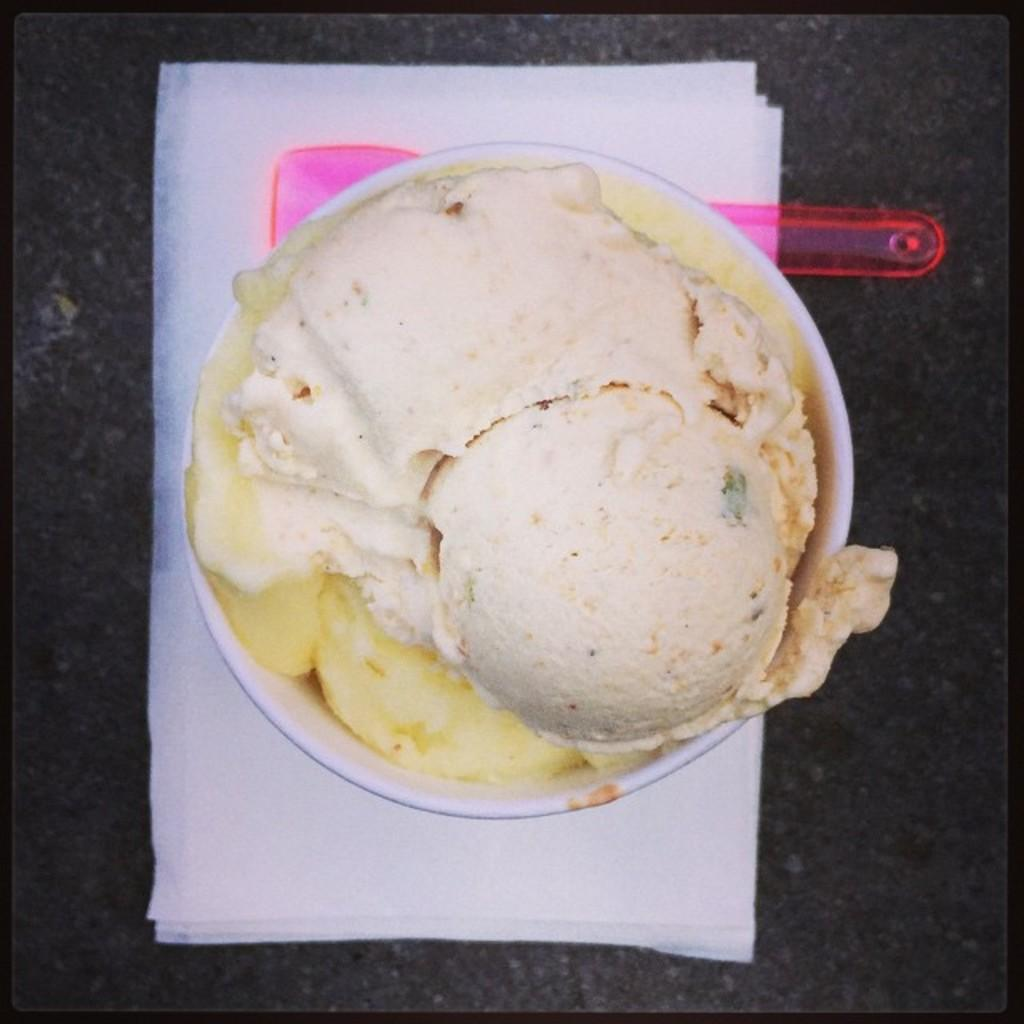What is in the bowl that is visible in the image? The bowl contains ice cream. What utensil is present in the image? There is a spoon in the image. Where is the bowl and spoon located? The bowl and spoon are on a paper. What is the paper resting on? The paper is on a stone slab. What time of day is it in the image, and is there a squirrel present? The time of day is not mentioned in the image, and there is no squirrel present. 